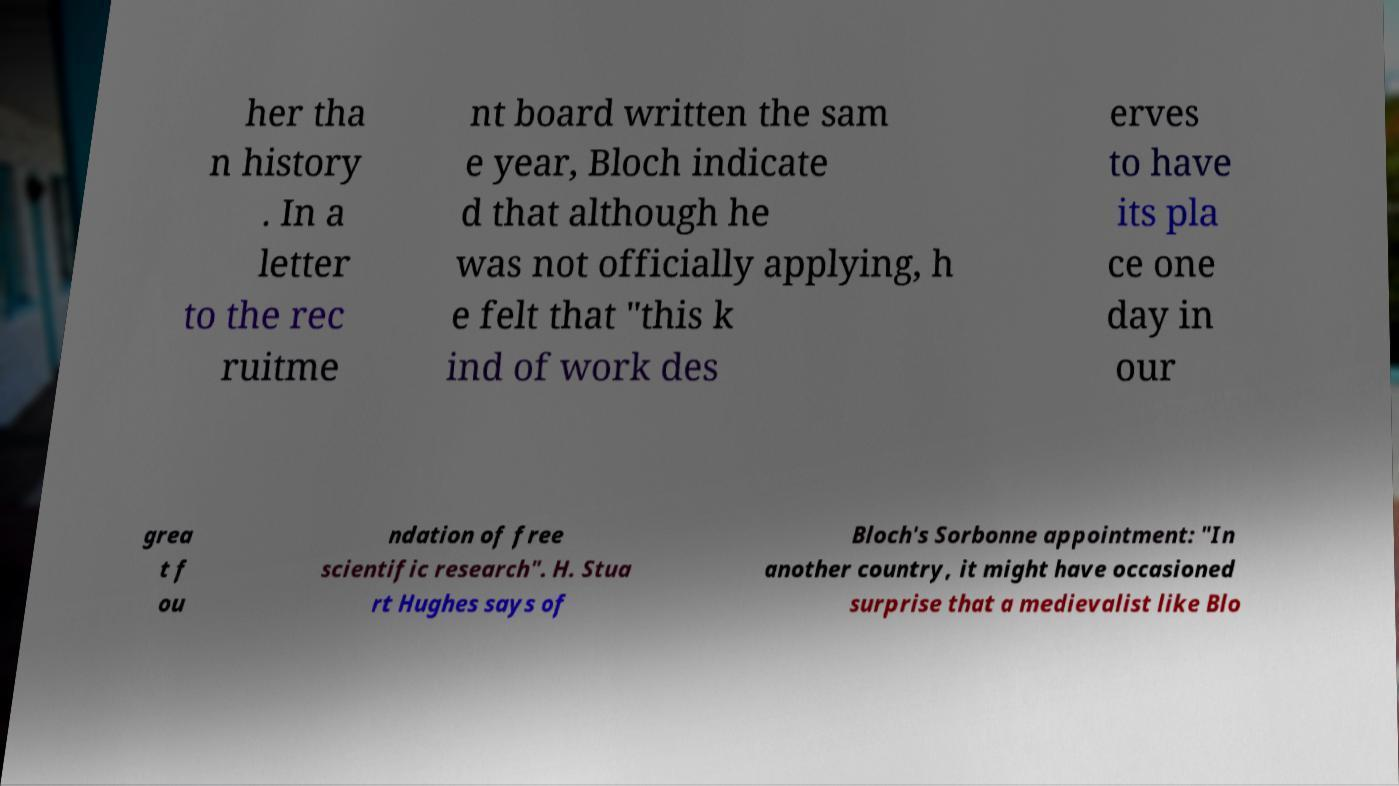Could you assist in decoding the text presented in this image and type it out clearly? her tha n history . In a letter to the rec ruitme nt board written the sam e year, Bloch indicate d that although he was not officially applying, h e felt that "this k ind of work des erves to have its pla ce one day in our grea t f ou ndation of free scientific research". H. Stua rt Hughes says of Bloch's Sorbonne appointment: "In another country, it might have occasioned surprise that a medievalist like Blo 